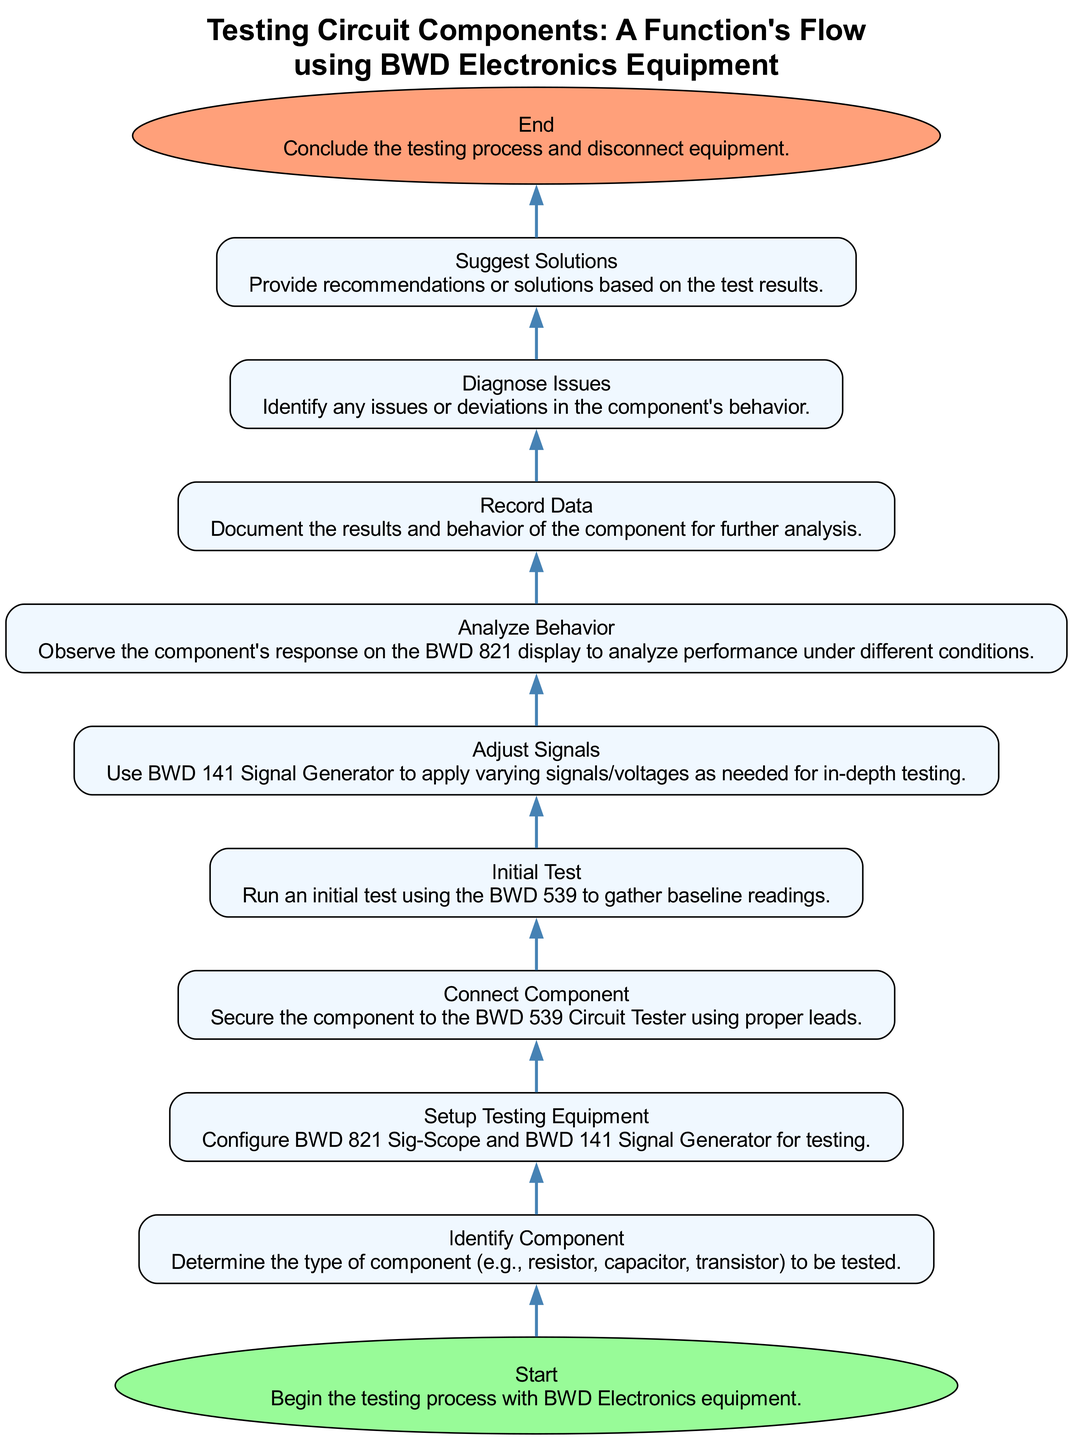What is the first step in the flowchart? The diagram starts with the "Start" node, indicating that the testing process begins here.
Answer: Start How many main steps are there in the flowchart? By counting each distinct node, we find there are a total of 11 steps involved in the testing process.
Answer: 11 What equipment is configured during the "Setup Testing Equipment" step? This step refers to configuring the "BWD 821 Sig-Scope" and "BWD 141 Signal Generator" for the testing process.
Answer: BWD 821 Sig-Scope and BWD 141 Signal Generator What action occurs after the "Connect Component" step? Following this step, the "Initial Test" is conducted using the BWD 539 Circuit Tester for baseline readings of the component.
Answer: Initial Test Which node follows "Analyze Behavior"? After analyzing the behavior of the component, the next action is to "Record Data" from the analysis conducted earlier.
Answer: Record Data If the test results indicate issues, what step follows "Diagnose Issues"? After diagnosing any issues or deviations, the next step includes providing recommendations or solutions based on these results.
Answer: Suggest Solutions What does the "End" node signify in this process? The "End" node indicates the conclusion of the entire testing process and the disconnection of the testing equipment.
Answer: Conclude the testing process Which node contains the specific action of observing the component's response? The node where the observation of the component's response occurs is labeled "Analyze Behavior."
Answer: Analyze Behavior What is the primary focus during the "Adjust Signals" step? The focus during this step is on using the BWD 141 Signal Generator to apply varying signals or voltages for in-depth testing.
Answer: Varying signals/voltages What is the main purpose of the "Record Data" step? The primary purpose of this step is to document the results and behavior of the component for further analysis after testing.
Answer: Document results and behavior 